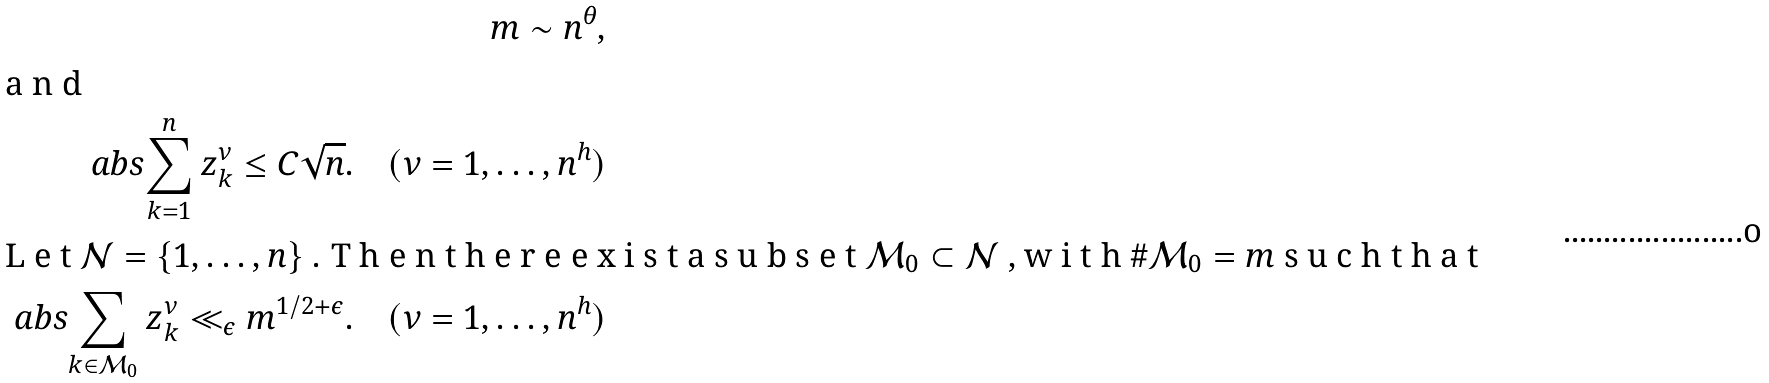<formula> <loc_0><loc_0><loc_500><loc_500>m \sim n ^ { \theta } , \\ \intertext { a n d } \ a b s { \sum _ { k = 1 } ^ { n } z _ { k } ^ { \nu } } \leq C \sqrt { n } . \quad ( \nu = 1 , \dots , n ^ { h } ) \\ \intertext { L e t $ \mathcal { N } = \{ 1 , \dots , n \} $ . T h e n t h e r e e x i s t a s u b s e t $ \mathcal { M } _ { 0 } \subset \mathcal { N } $ , w i t h $ \# \mathcal { M } _ { 0 } = m $ s u c h t h a t } \ a b s { \sum _ { k \in \mathcal { M } _ { 0 } } z _ { k } ^ { \nu } } \ll _ { \epsilon } m ^ { 1 / 2 + \epsilon } . \quad ( \nu = 1 , \dots , n ^ { h } )</formula> 